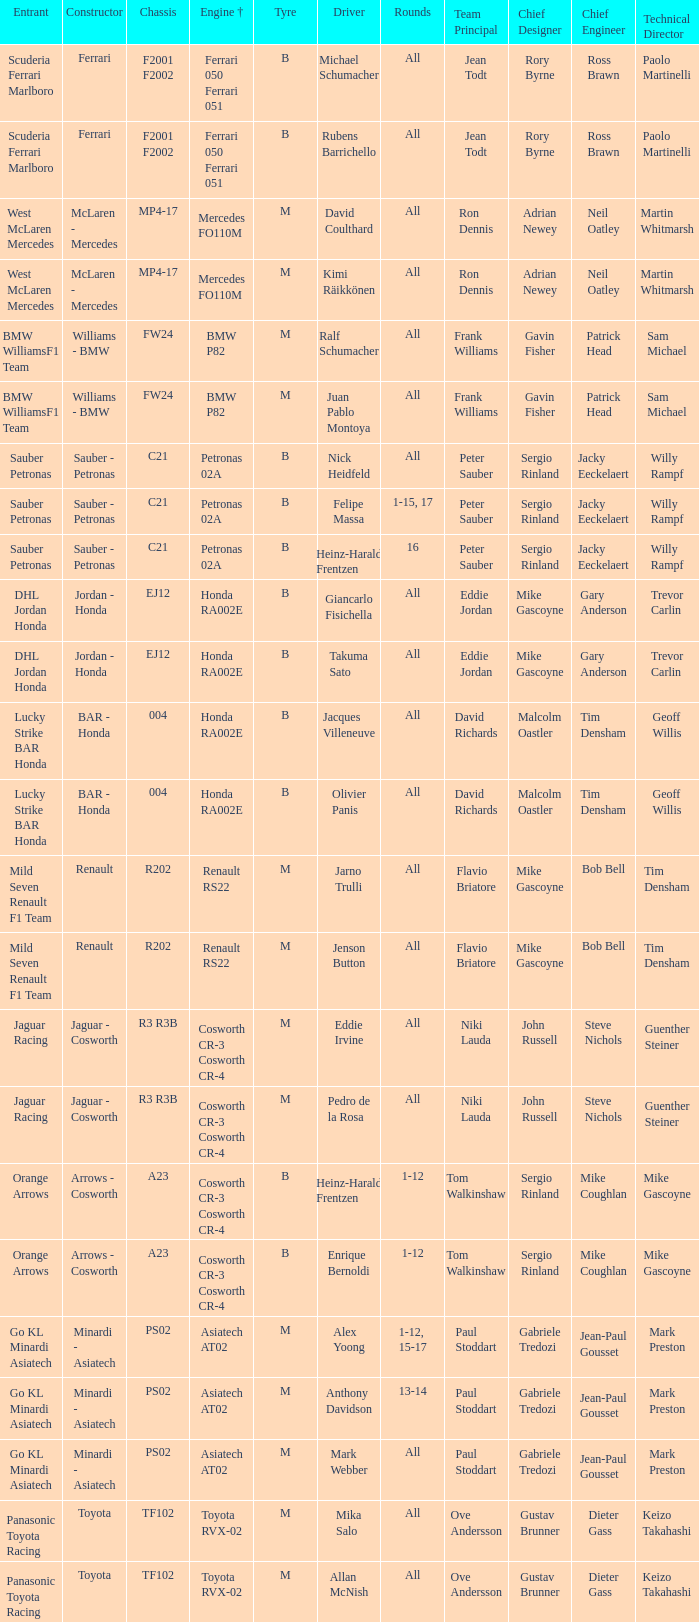What is the engine when the rounds ar all, the tyre is m and the driver is david coulthard? Mercedes FO110M. 